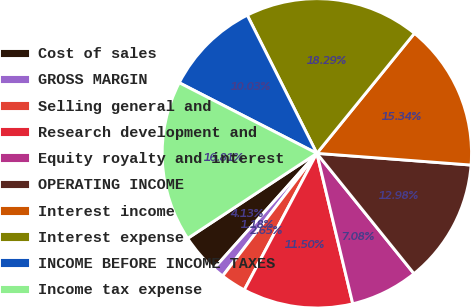<chart> <loc_0><loc_0><loc_500><loc_500><pie_chart><fcel>Cost of sales<fcel>GROSS MARGIN<fcel>Selling general and<fcel>Research development and<fcel>Equity royalty and interest<fcel>OPERATING INCOME<fcel>Interest income<fcel>Interest expense<fcel>INCOME BEFORE INCOME TAXES<fcel>Income tax expense<nl><fcel>4.13%<fcel>1.18%<fcel>2.65%<fcel>11.5%<fcel>7.08%<fcel>12.98%<fcel>15.34%<fcel>18.29%<fcel>10.03%<fcel>16.81%<nl></chart> 